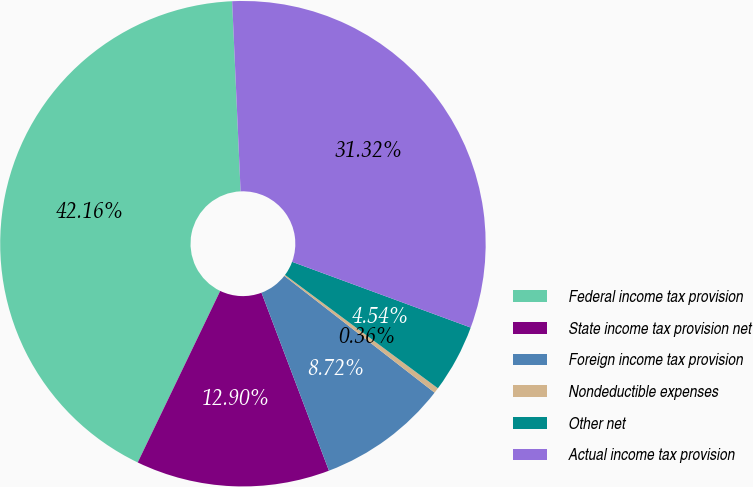<chart> <loc_0><loc_0><loc_500><loc_500><pie_chart><fcel>Federal income tax provision<fcel>State income tax provision net<fcel>Foreign income tax provision<fcel>Nondeductible expenses<fcel>Other net<fcel>Actual income tax provision<nl><fcel>42.16%<fcel>12.9%<fcel>8.72%<fcel>0.36%<fcel>4.54%<fcel>31.32%<nl></chart> 